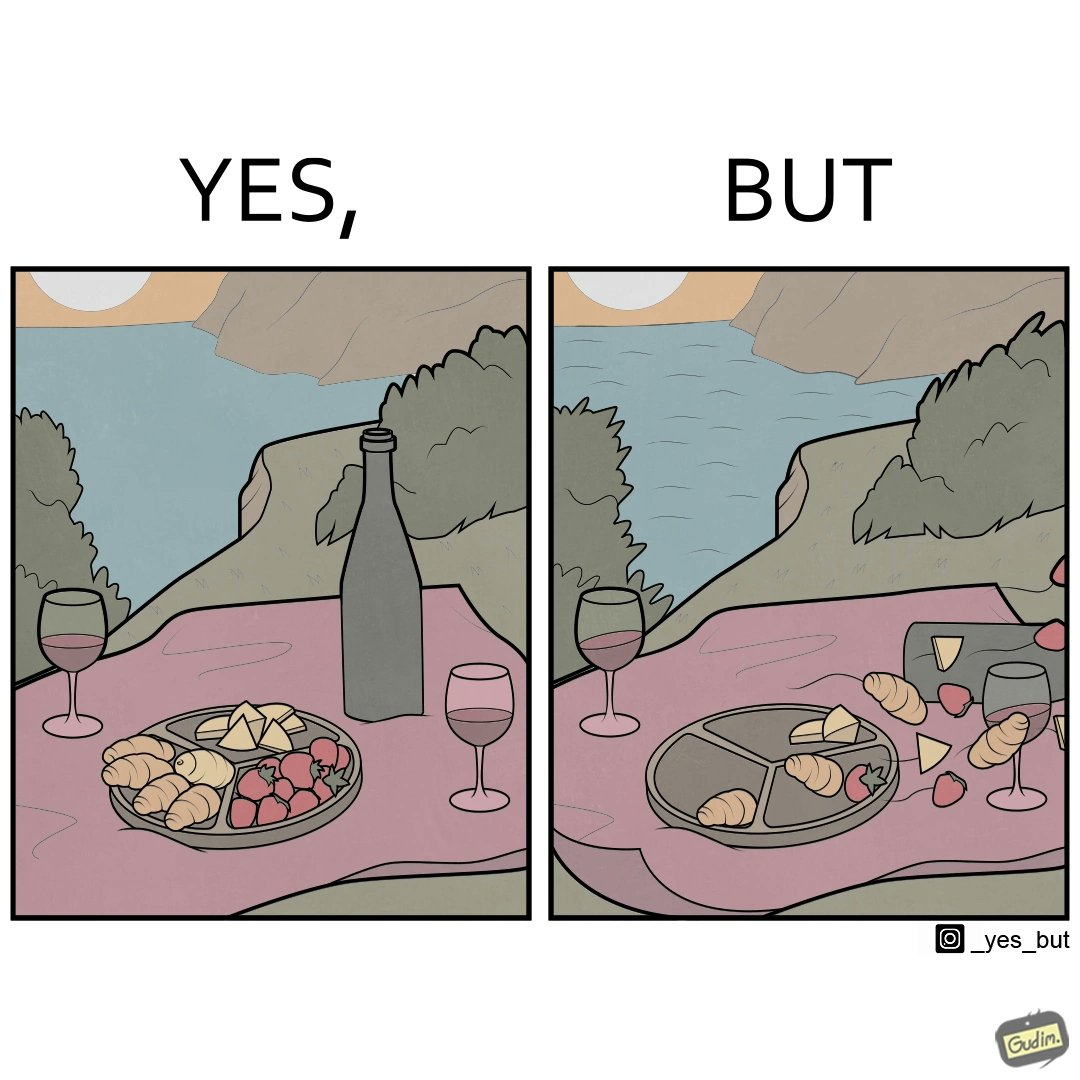What is the satirical meaning behind this image? The environment is feeling very relaxing in the right image but the consequence is that the food is flying die to powerful wind. So the person is not able to eat it properly. 